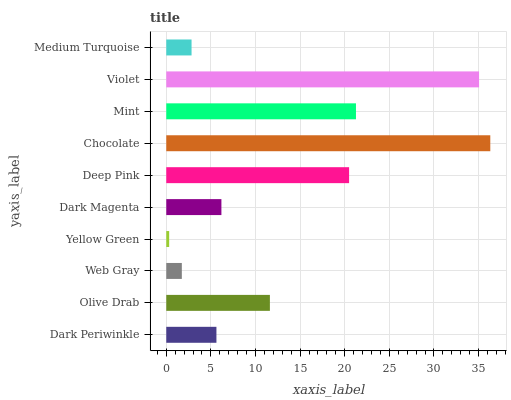Is Yellow Green the minimum?
Answer yes or no. Yes. Is Chocolate the maximum?
Answer yes or no. Yes. Is Olive Drab the minimum?
Answer yes or no. No. Is Olive Drab the maximum?
Answer yes or no. No. Is Olive Drab greater than Dark Periwinkle?
Answer yes or no. Yes. Is Dark Periwinkle less than Olive Drab?
Answer yes or no. Yes. Is Dark Periwinkle greater than Olive Drab?
Answer yes or no. No. Is Olive Drab less than Dark Periwinkle?
Answer yes or no. No. Is Olive Drab the high median?
Answer yes or no. Yes. Is Dark Magenta the low median?
Answer yes or no. Yes. Is Violet the high median?
Answer yes or no. No. Is Medium Turquoise the low median?
Answer yes or no. No. 